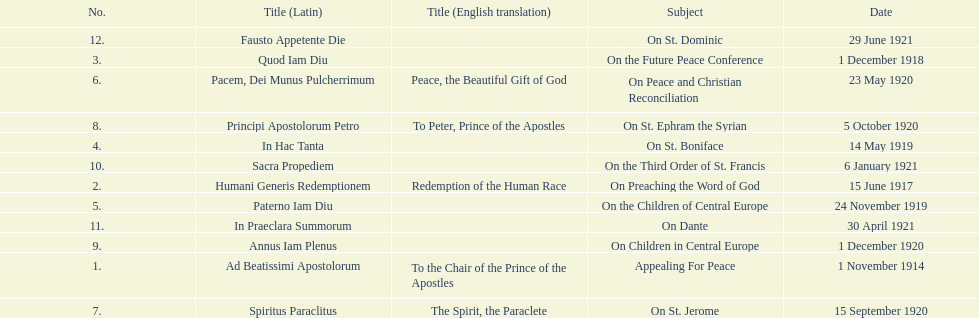What was the number of encyclopedias that had subjects relating specifically to children? 2. 